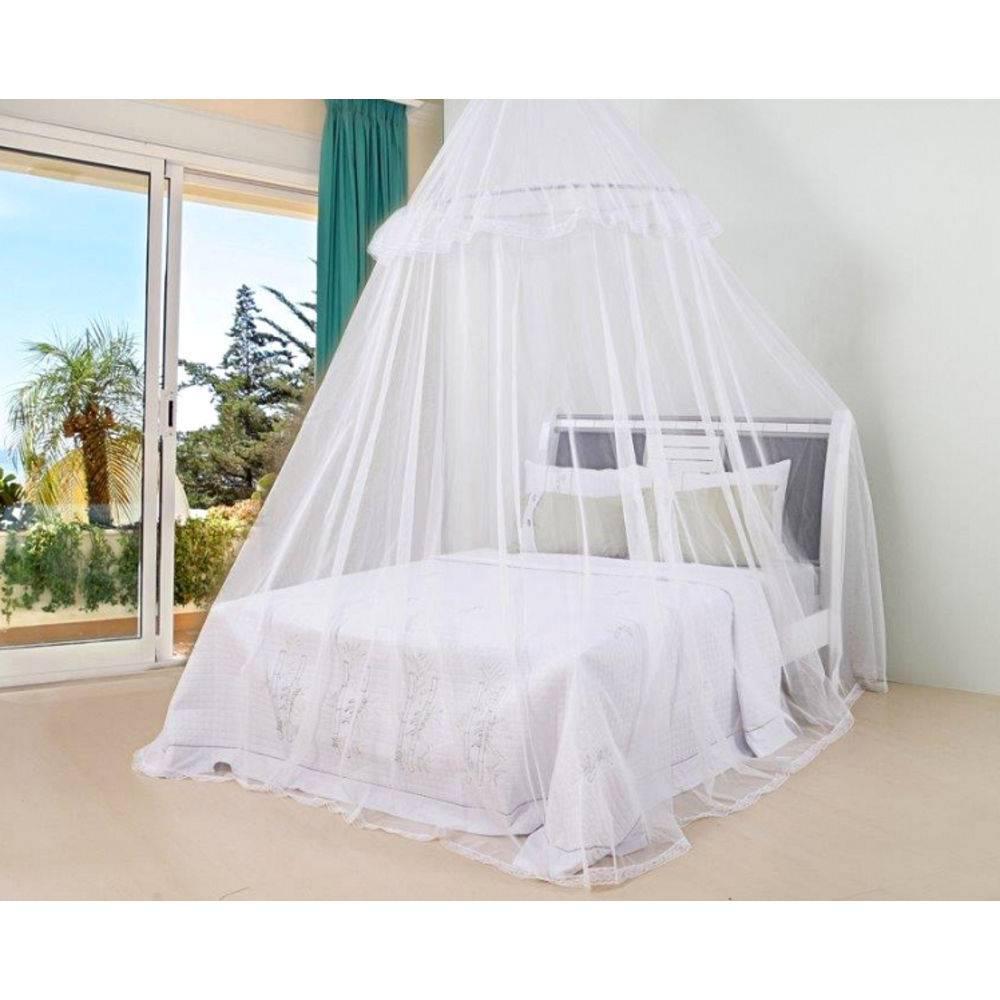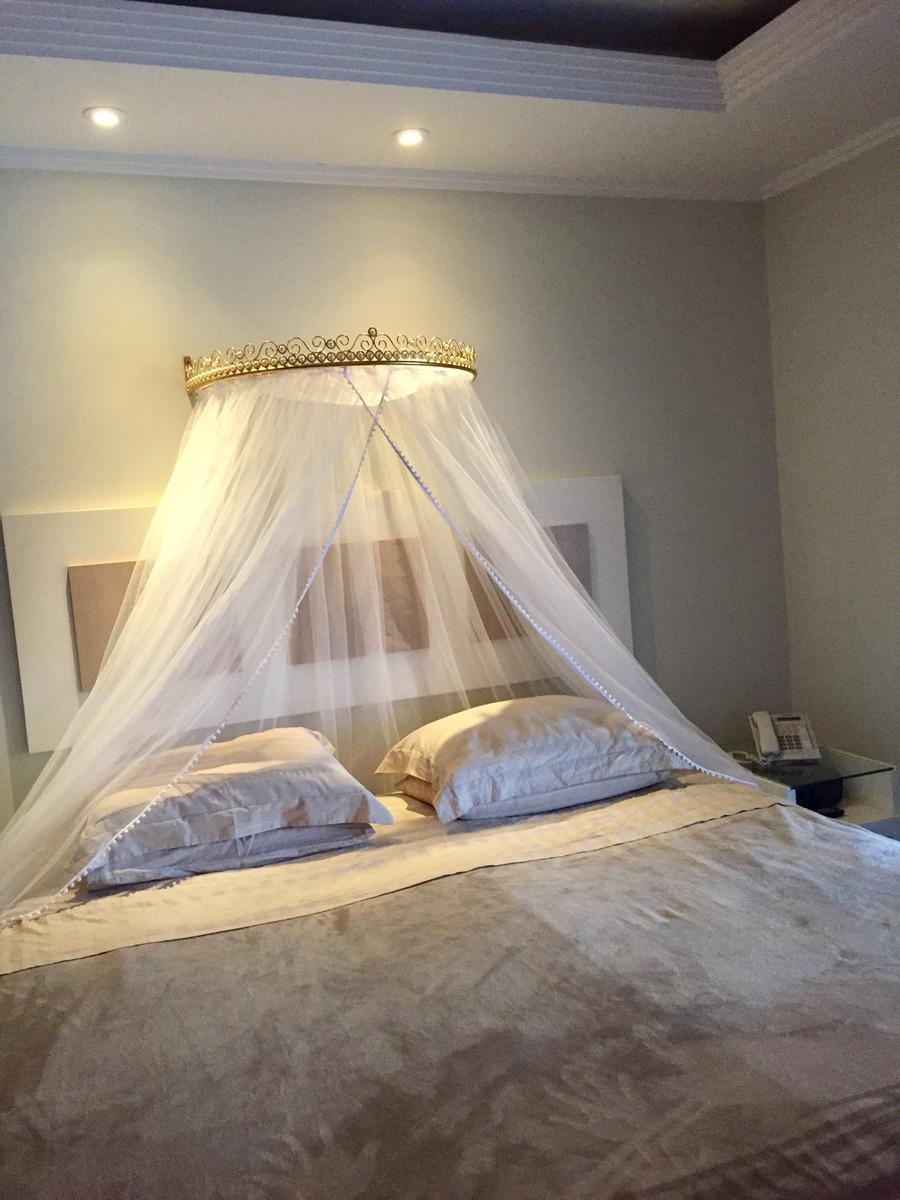The first image is the image on the left, the second image is the image on the right. Assess this claim about the two images: "There are two white canopies; one hanging from the ceiling and the other mounted on the back wall.". Correct or not? Answer yes or no. Yes. 